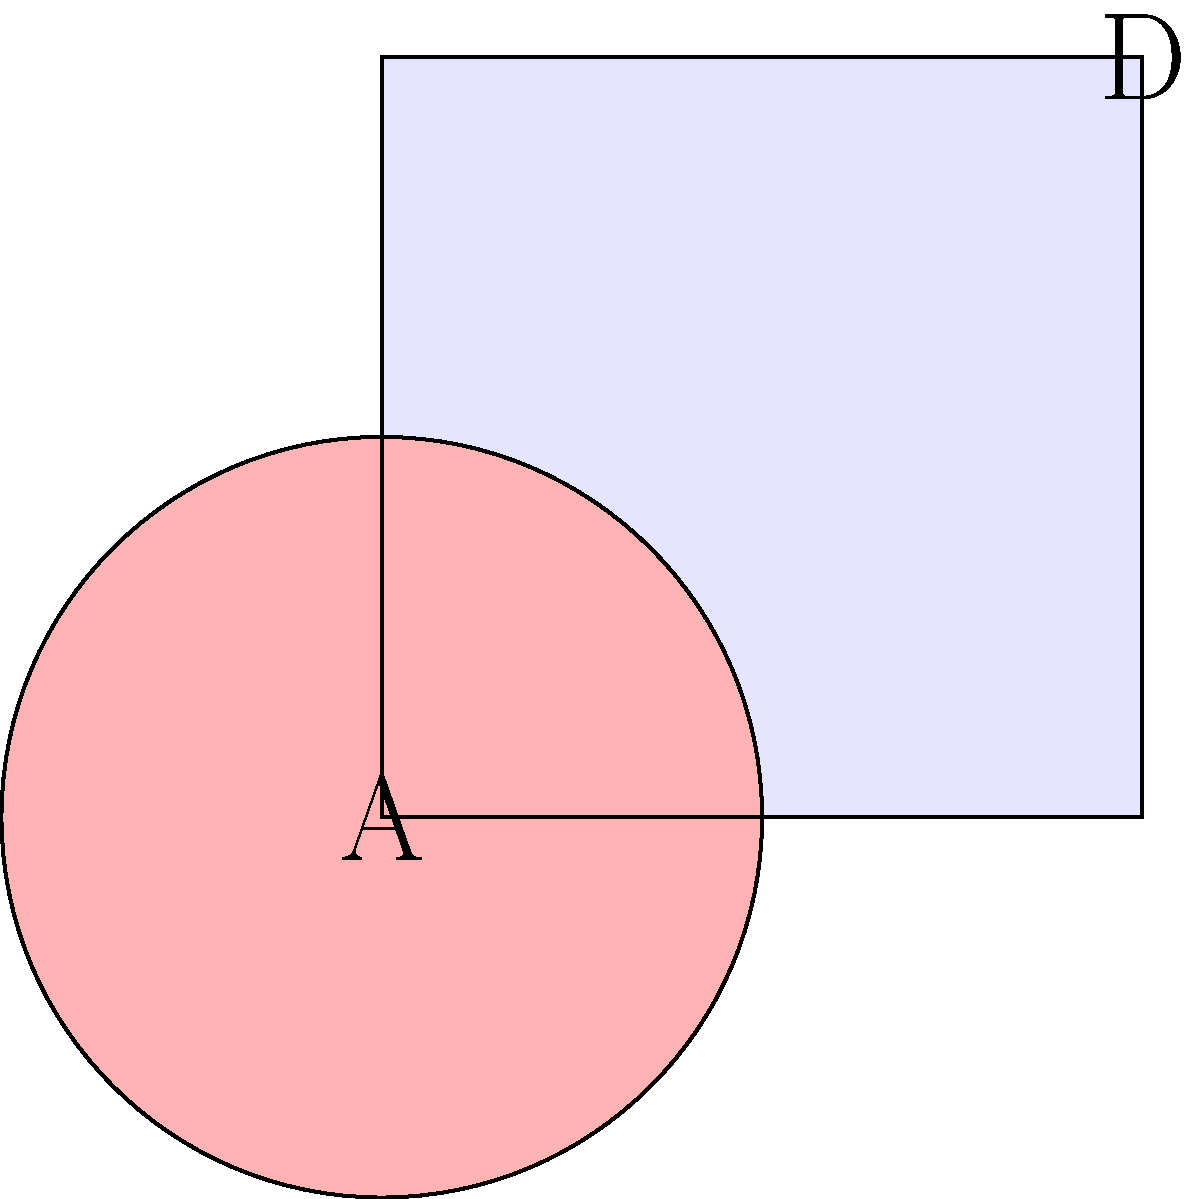In the image above, geometric shapes are used to represent Nietzsche's concept of Apollonian and Dionysian forces. Which shape and color combination best represents the Apollonian force, and why does this align with Nietzsche's philosophical ideas? To answer this question, let's break down the key elements:

1. Nietzsche's concept of Apollonian and Dionysian forces:
   - Apollonian: Represents order, reason, clarity, and form.
   - Dionysian: Represents chaos, emotion, intoxication, and formlessness.

2. Geometric shapes in the image:
   - Square: Regular, structured, predictable.
   - Circle: Continuous, fluid, without clear boundaries.

3. Colors used:
   - Light blue: Cool, calm, rational.
   - Light red: Warm, passionate, energetic.

4. Analysis:
   - The square in light blue best represents the Apollonian force because:
     a) The square's straight lines and right angles embody order and structure.
     b) The light blue color evokes a sense of calmness and rationality.

5. Alignment with Nietzsche's ideas:
   - Nietzsche viewed the Apollonian as the force of individuation and rational thinking.
   - The square's defined boundaries reflect the Apollonian principle of clear form and separation.
   - The cool blue color reinforces the idea of clarity and intellectual distance associated with Apollonian thinking.

In contrast, the circle in light red represents the Dionysian force, with its lack of corners symbolizing the dissolution of boundaries and its warm color evoking passion and emotion.
Answer: The square in light blue represents the Apollonian force, aligning with Nietzsche's concept of order, reason, and form. 